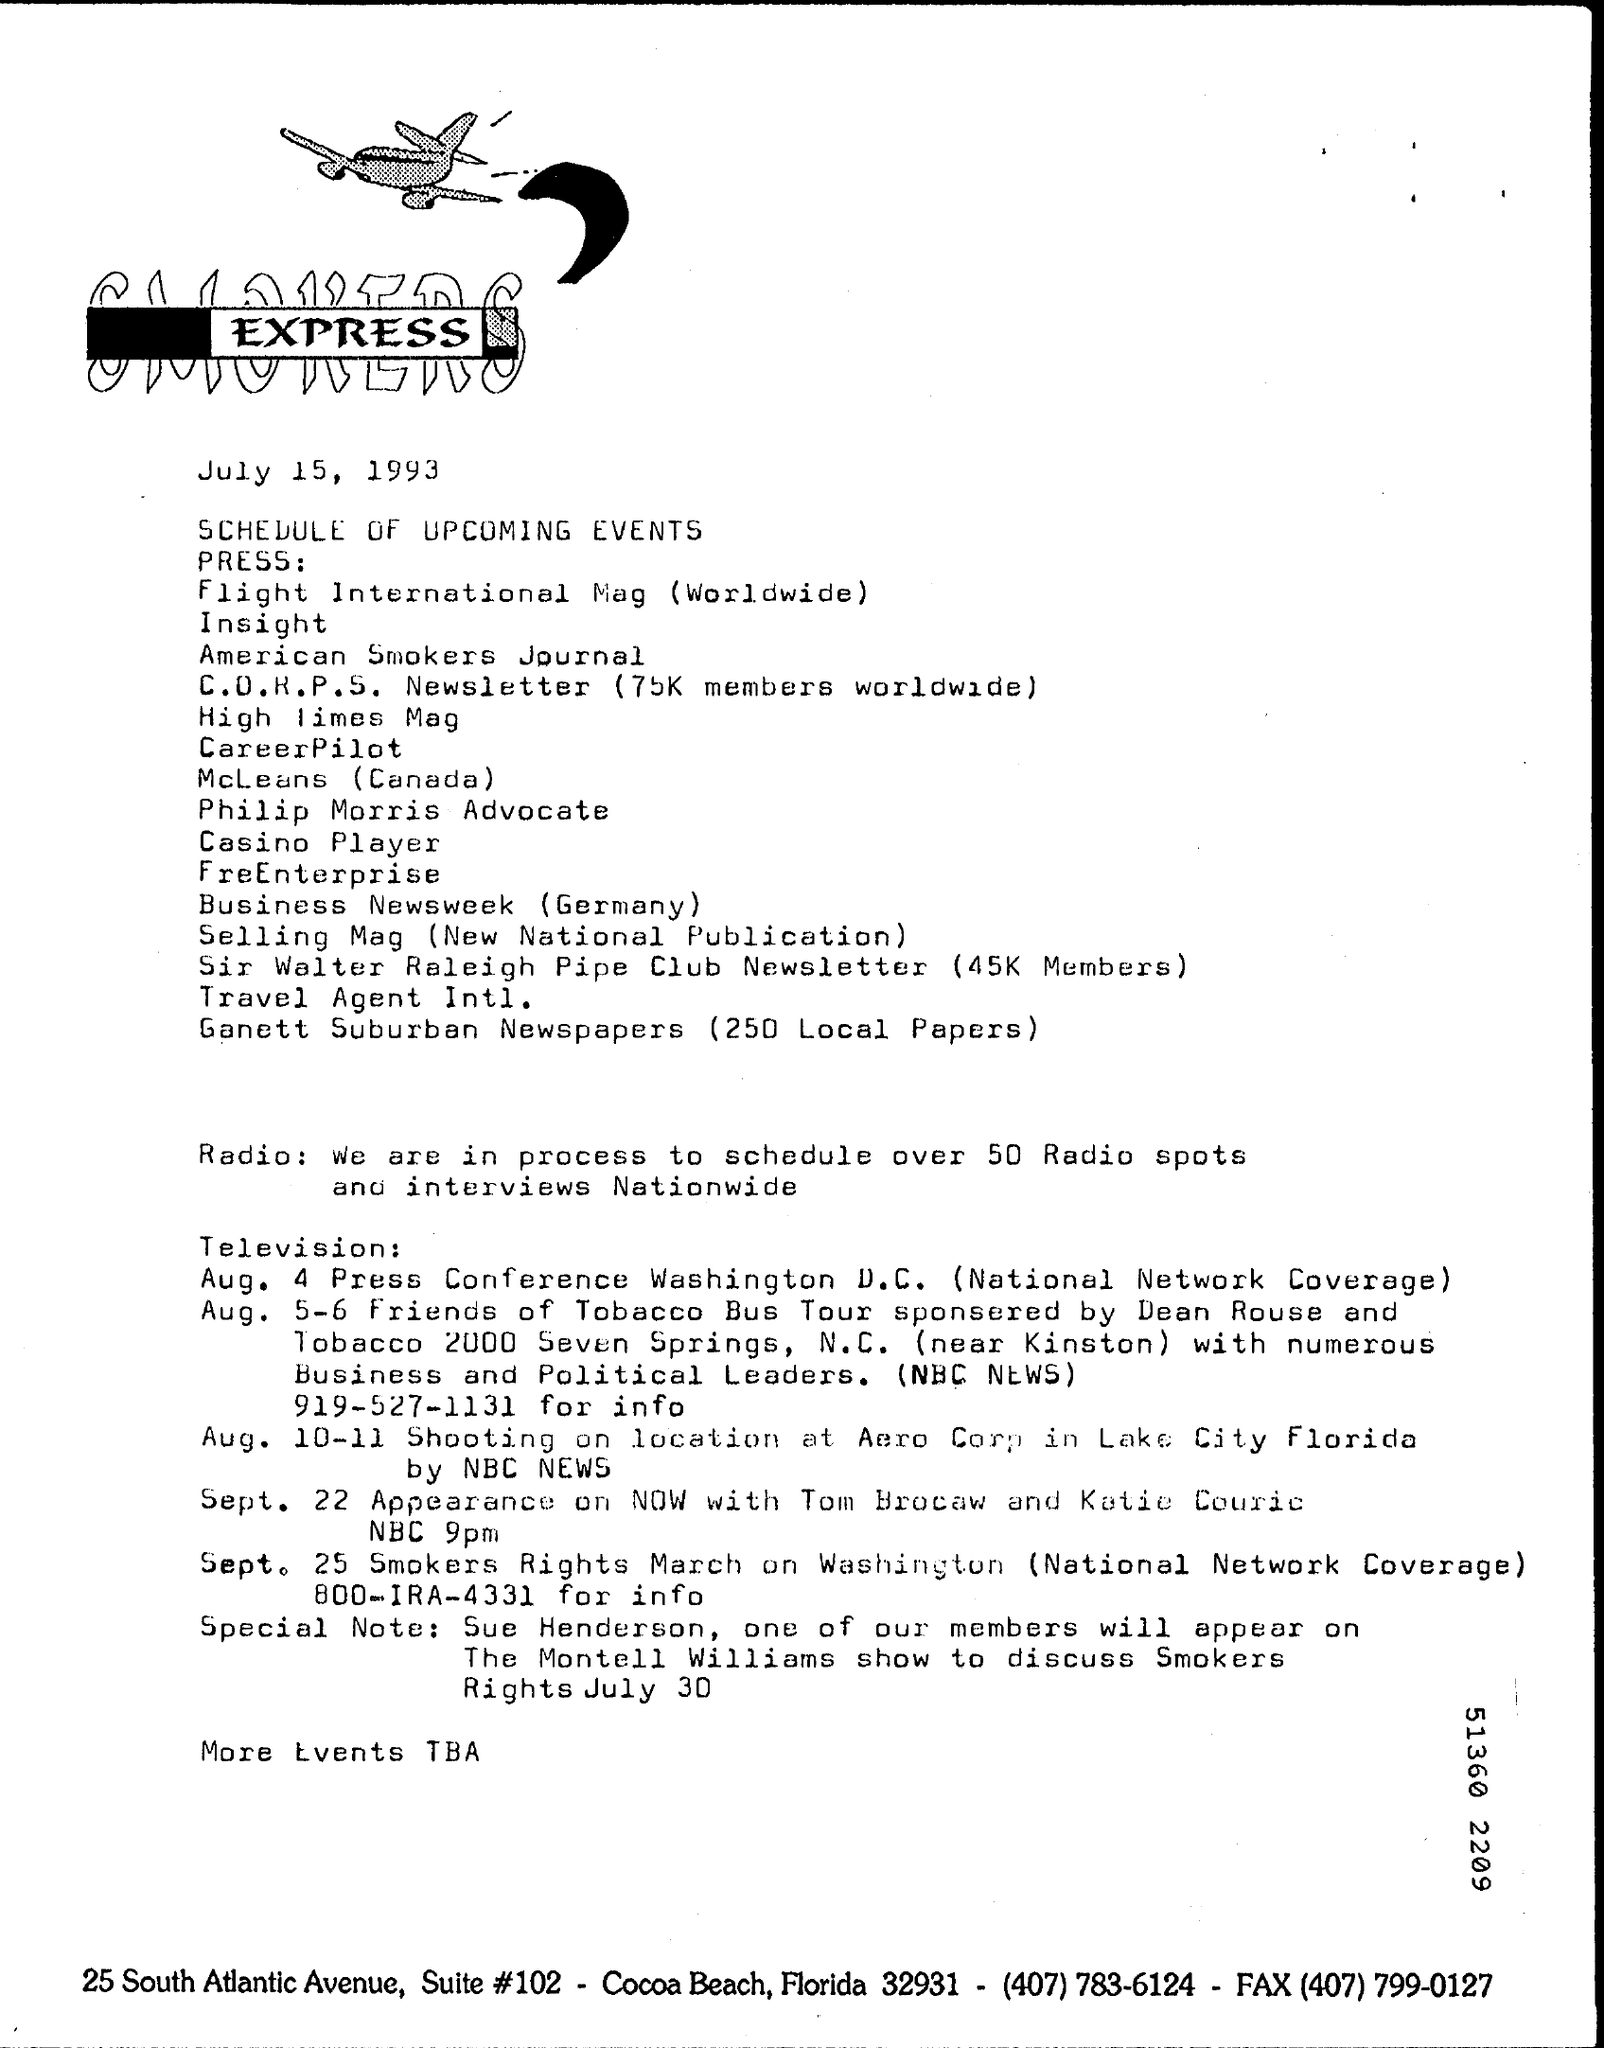What is the Fax?
Give a very brief answer. (407) 799-0127. When is the Press Conference in Washington D.C.?
Your response must be concise. Aug 4. 